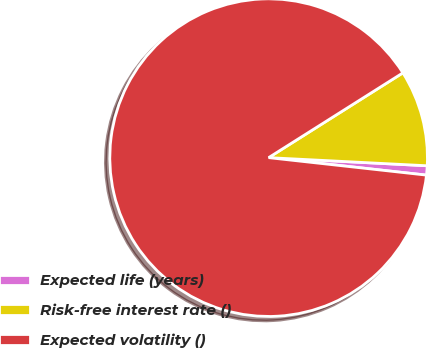<chart> <loc_0><loc_0><loc_500><loc_500><pie_chart><fcel>Expected life (years)<fcel>Risk-free interest rate ()<fcel>Expected volatility ()<nl><fcel>0.94%<fcel>9.78%<fcel>89.28%<nl></chart> 